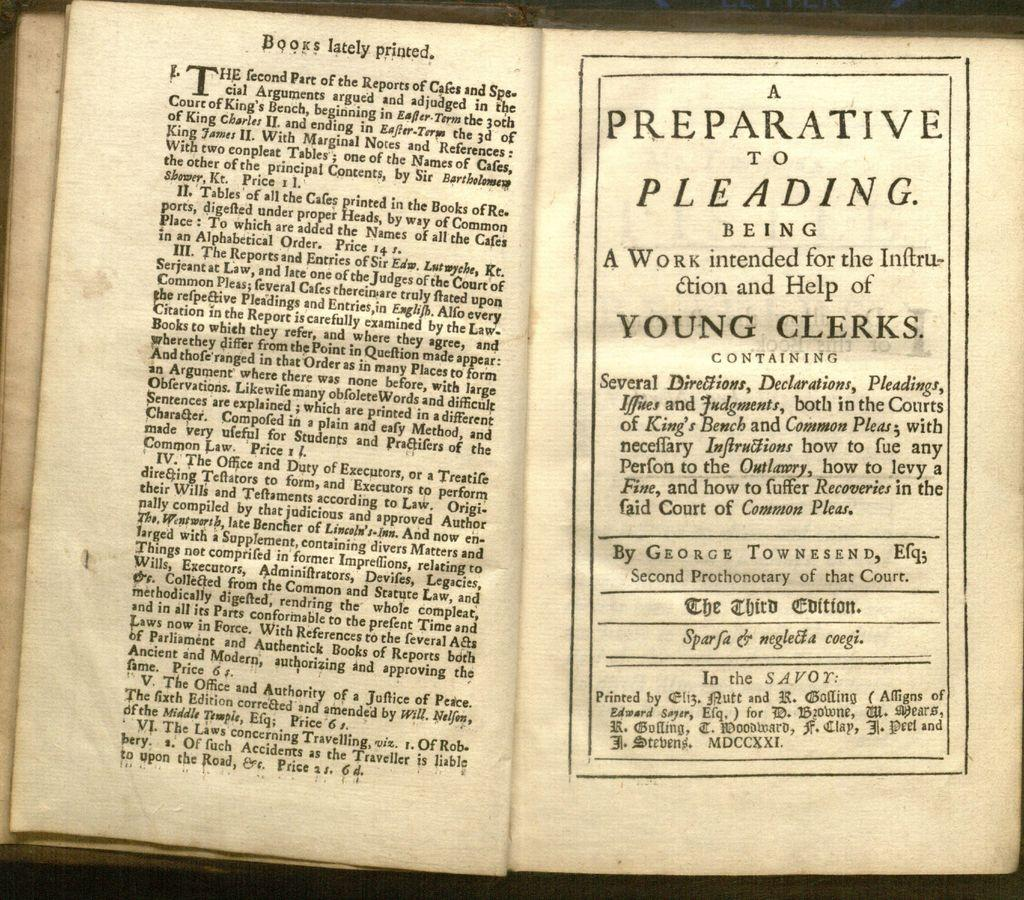<image>
Give a short and clear explanation of the subsequent image. An opened book where the writings of George Townsend is displayed. 